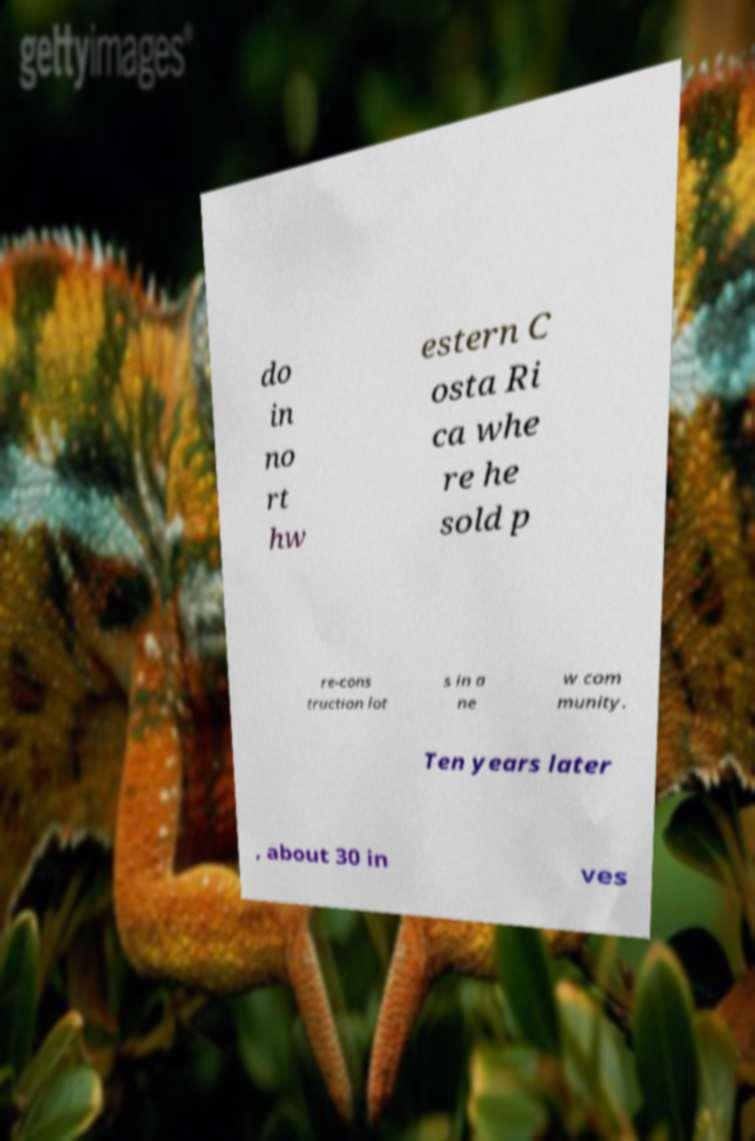Please read and relay the text visible in this image. What does it say? do in no rt hw estern C osta Ri ca whe re he sold p re-cons truction lot s in a ne w com munity. Ten years later , about 30 in ves 